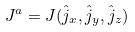Convert formula to latex. <formula><loc_0><loc_0><loc_500><loc_500>J ^ { a } = J ( \hat { j } _ { x } , \hat { j } _ { y } , \hat { j } _ { z } )</formula> 